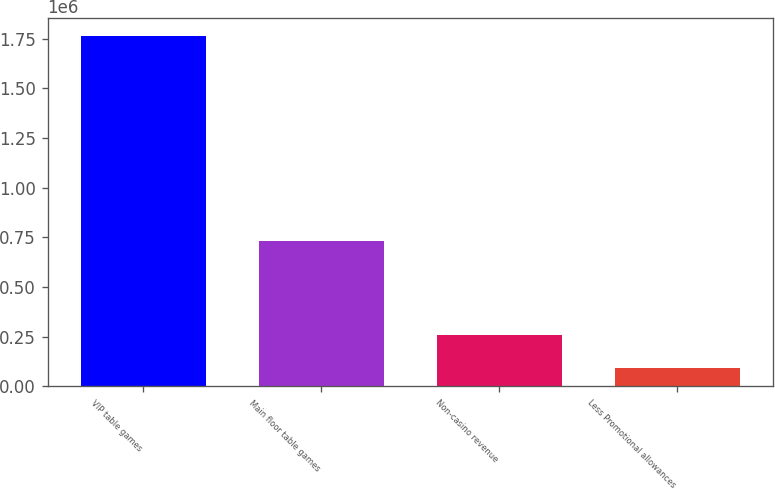<chart> <loc_0><loc_0><loc_500><loc_500><bar_chart><fcel>VIP table games<fcel>Main floor table games<fcel>Non-casino revenue<fcel>Less Promotional allowances<nl><fcel>1.76263e+06<fcel>733397<fcel>260586<fcel>93692<nl></chart> 